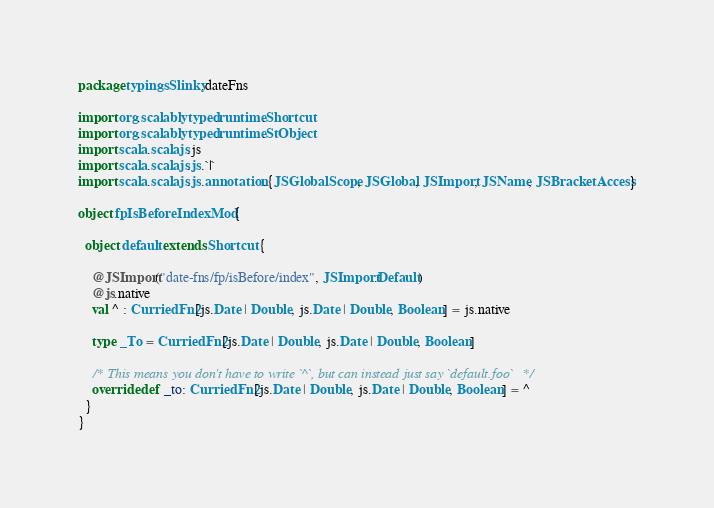Convert code to text. <code><loc_0><loc_0><loc_500><loc_500><_Scala_>package typingsSlinky.dateFns

import org.scalablytyped.runtime.Shortcut
import org.scalablytyped.runtime.StObject
import scala.scalajs.js
import scala.scalajs.js.`|`
import scala.scalajs.js.annotation.{JSGlobalScope, JSGlobal, JSImport, JSName, JSBracketAccess}

object fpIsBeforeIndexMod {
  
  object default extends Shortcut {
    
    @JSImport("date-fns/fp/isBefore/index", JSImport.Default)
    @js.native
    val ^ : CurriedFn2[js.Date | Double, js.Date | Double, Boolean] = js.native
    
    type _To = CurriedFn2[js.Date | Double, js.Date | Double, Boolean]
    
    /* This means you don't have to write `^`, but can instead just say `default.foo` */
    override def _to: CurriedFn2[js.Date | Double, js.Date | Double, Boolean] = ^
  }
}
</code> 